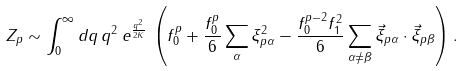Convert formula to latex. <formula><loc_0><loc_0><loc_500><loc_500>Z _ { p } \sim \int _ { 0 } ^ { \infty } d q \, q ^ { 2 } \, e ^ { \frac { q ^ { 2 } } { 2 K } } \, \left ( f _ { 0 } ^ { p } + \frac { f _ { 0 } ^ { p } } { 6 } \sum _ { \alpha } \xi _ { p \alpha } ^ { 2 } - \frac { f _ { 0 } ^ { p - 2 } f _ { 1 } ^ { 2 } } { 6 } \sum _ { \alpha \neq \beta } \vec { \xi } _ { p \alpha } \cdot \vec { \xi } _ { p \beta } \right ) .</formula> 